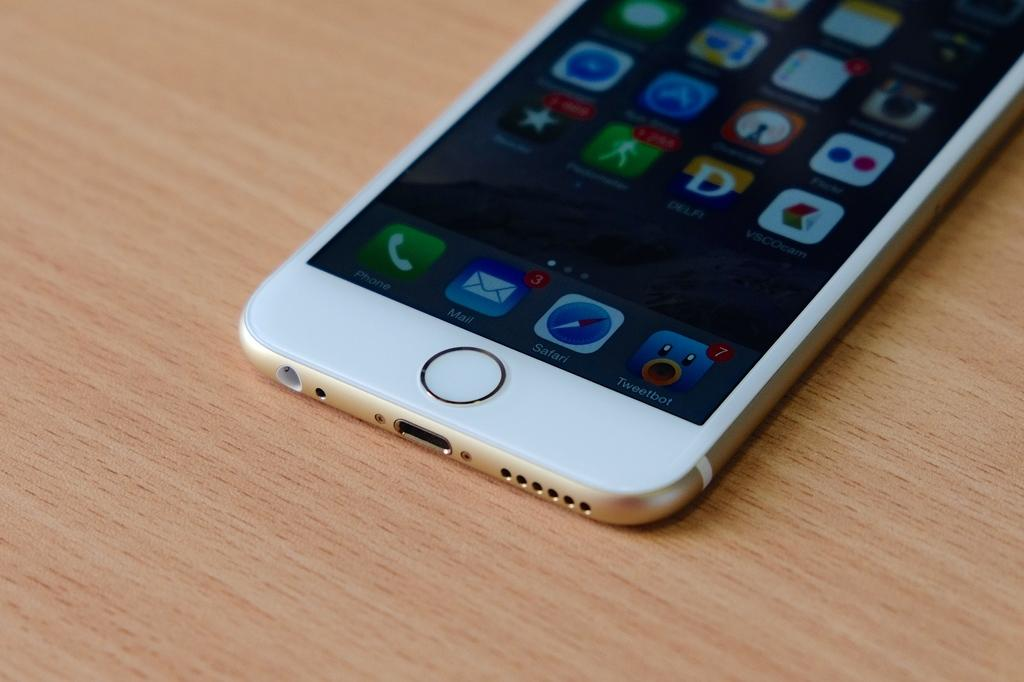What is the color of the surface in the image? The surface in the image is brown in color. What object can be seen on the surface? There is a phone on the surface. What is visible on the phone's screen? The phone's screen displays applications and words. How much salt is visible on the surface in the image? There is no salt visible on the surface in the image. Is there a yard visible in the image? The image does not show a yard; it only shows a phone on a brown surface. 